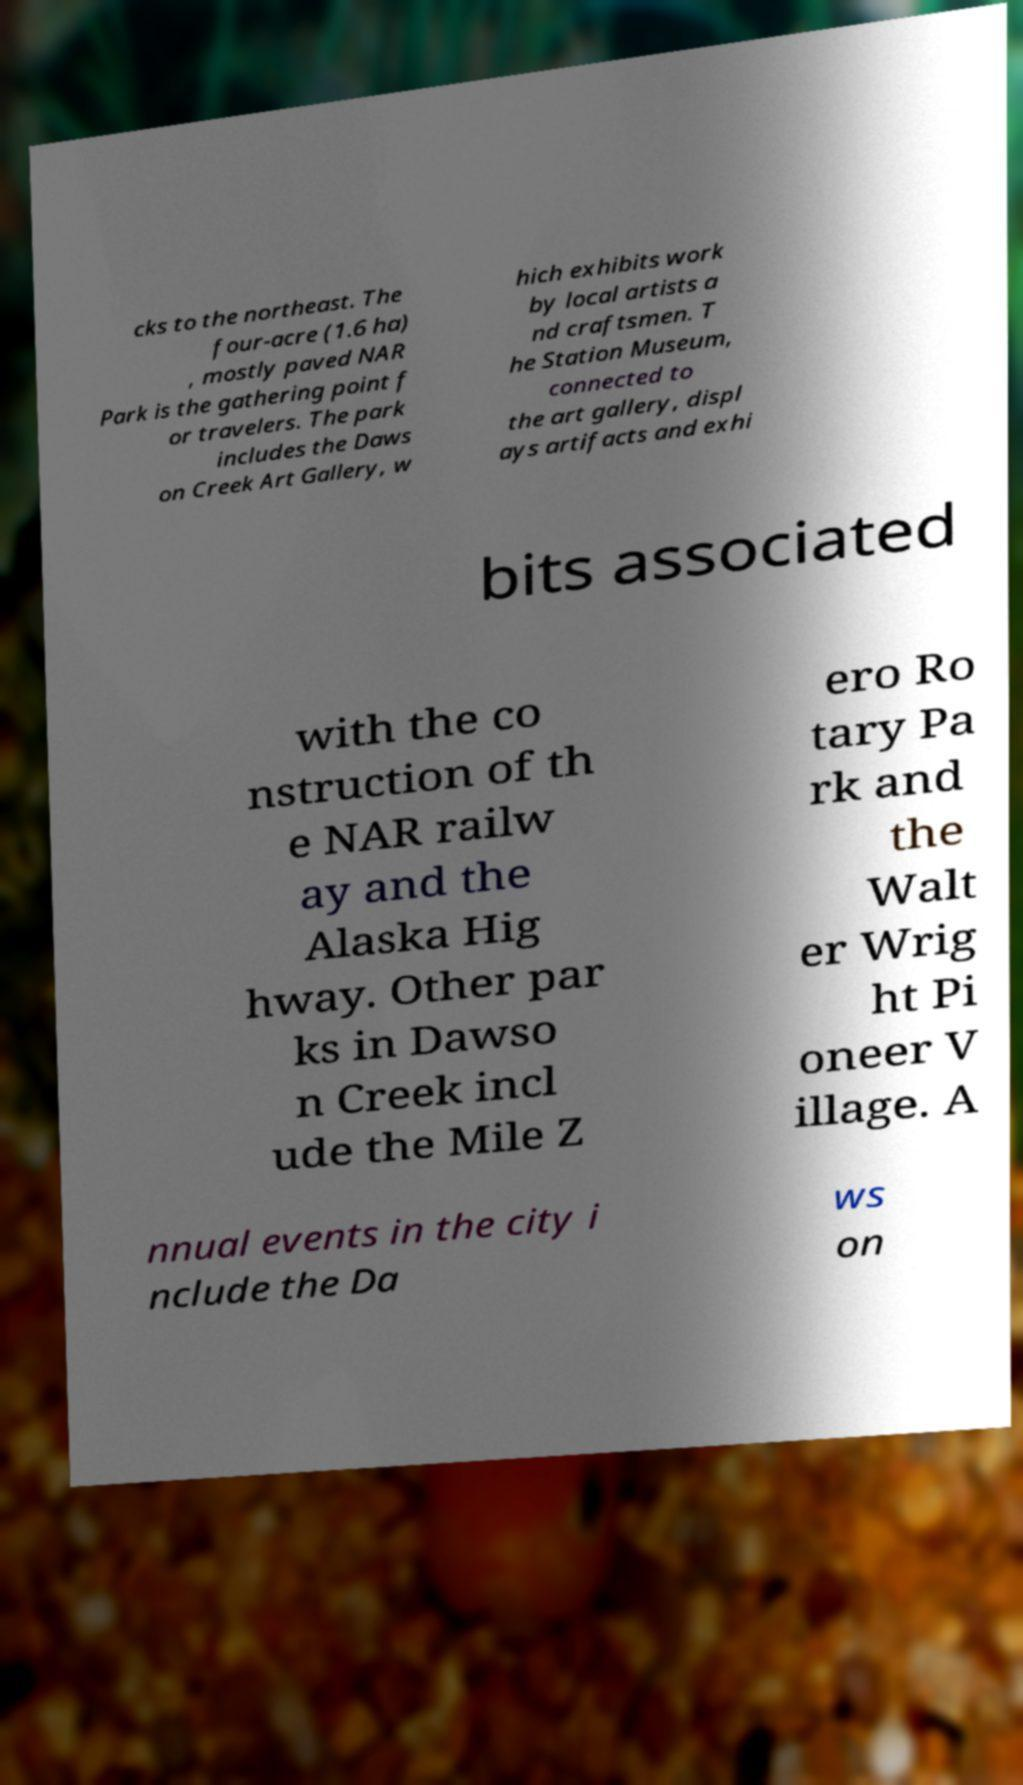I need the written content from this picture converted into text. Can you do that? cks to the northeast. The four-acre (1.6 ha) , mostly paved NAR Park is the gathering point f or travelers. The park includes the Daws on Creek Art Gallery, w hich exhibits work by local artists a nd craftsmen. T he Station Museum, connected to the art gallery, displ ays artifacts and exhi bits associated with the co nstruction of th e NAR railw ay and the Alaska Hig hway. Other par ks in Dawso n Creek incl ude the Mile Z ero Ro tary Pa rk and the Walt er Wrig ht Pi oneer V illage. A nnual events in the city i nclude the Da ws on 